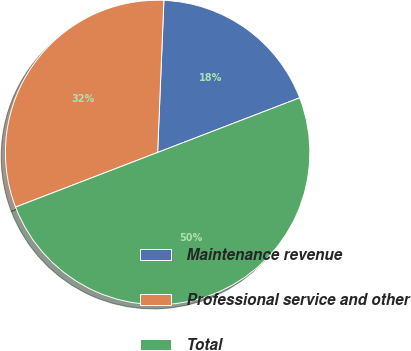<chart> <loc_0><loc_0><loc_500><loc_500><pie_chart><fcel>Maintenance revenue<fcel>Professional service and other<fcel>Total<nl><fcel>18.5%<fcel>31.5%<fcel>50.0%<nl></chart> 